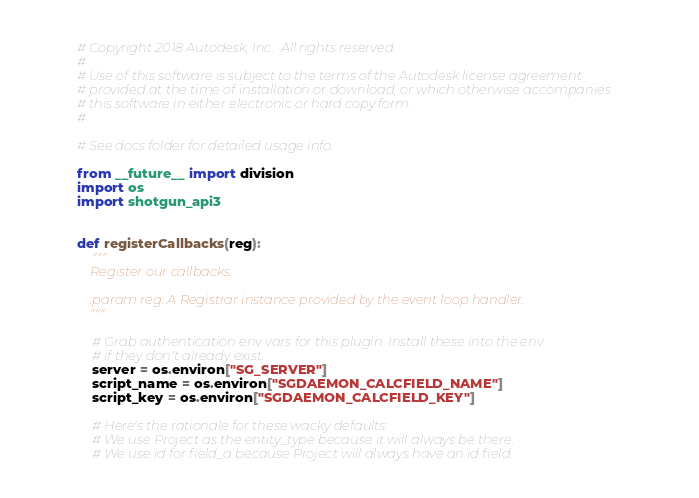Convert code to text. <code><loc_0><loc_0><loc_500><loc_500><_Python_># Copyright 2018 Autodesk, Inc.  All rights reserved.
#
# Use of this software is subject to the terms of the Autodesk license agreement
# provided at the time of installation or download, or which otherwise accompanies
# this software in either electronic or hard copy form.
#

# See docs folder for detailed usage info.

from __future__ import division
import os
import shotgun_api3


def registerCallbacks(reg):
    """
    Register our callbacks.

    :param reg: A Registrar instance provided by the event loop handler.
    """

    # Grab authentication env vars for this plugin. Install these into the env
    # if they don't already exist.
    server = os.environ["SG_SERVER"]
    script_name = os.environ["SGDAEMON_CALCFIELD_NAME"]
    script_key = os.environ["SGDAEMON_CALCFIELD_KEY"]

    # Here's the rationale for these wacky defaults:
    # We use Project as the entity_type because it will always be there.
    # We use id for field_a because Project will always have an id field.</code> 